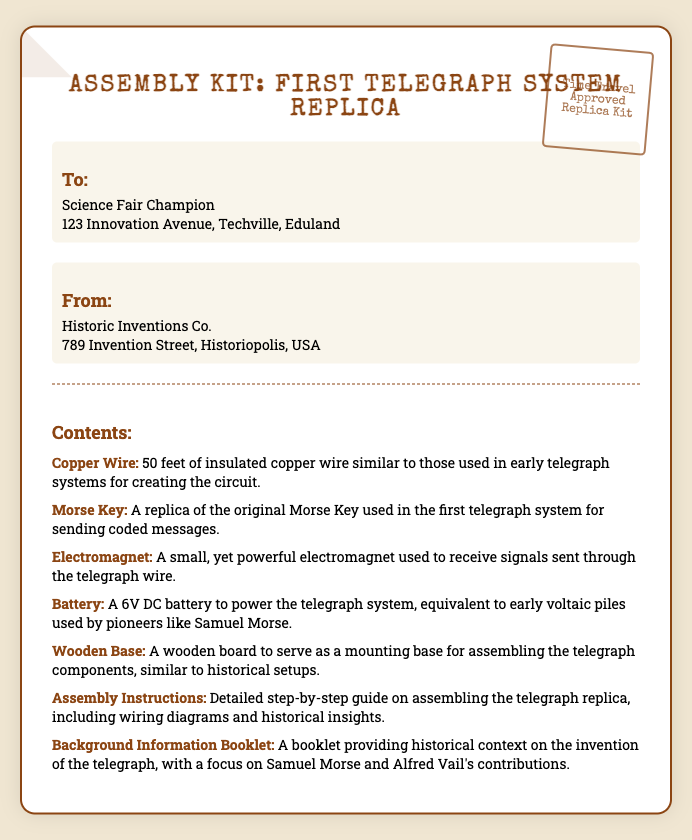What is the title of the kit? The title of the kit is presented prominently at the top of the document, indicating it is an assembly kit for a replica of the first telegraph system.
Answer: Assembly Kit: First Telegraph System Replica Who is the recipient of the parcel? The recipient's name and address are clearly stated in the document under the "To:" section.
Answer: Science Fair Champion What is included in the contents list? The document lists various items included in the kit, and the contents section explicitly details each component necessary for the assembly.
Answer: Copper Wire, Morse Key, Electromagnet, Battery, Wooden Base, Assembly Instructions, Background Information Booklet How many feet of copper wire are provided? The quantity of copper wire included is detailed in the contents section, providing a specific measurement.
Answer: 50 feet What type of battery is included? The type of battery is specified in the contents section, highlighting its usage in the telegraph system.
Answer: 6V DC battery What kind of instructions are provided? The document describes the nature of the instructions available in the kit, emphasizing their detail and purpose.
Answer: Detailed step-by-step guide Who is the sender of the parcel? The sender's name and address are identified in the document under the "From:" section, indicating where the kit originated.
Answer: Historic Inventions Co What historical figures are mentioned in the background information? The background information booklet includes specific contributions from historical figures associated with the telegraph.
Answer: Samuel Morse and Alfred Vail What is the purpose of the wooden base? The document describes the function of the wooden base in relation to the assembly of the telegraph components.
Answer: Serving as a mounting base 